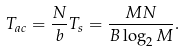<formula> <loc_0><loc_0><loc_500><loc_500>T _ { a c } = \frac { N } { b } T _ { s } = \frac { M N } { B \log _ { 2 } M } .</formula> 